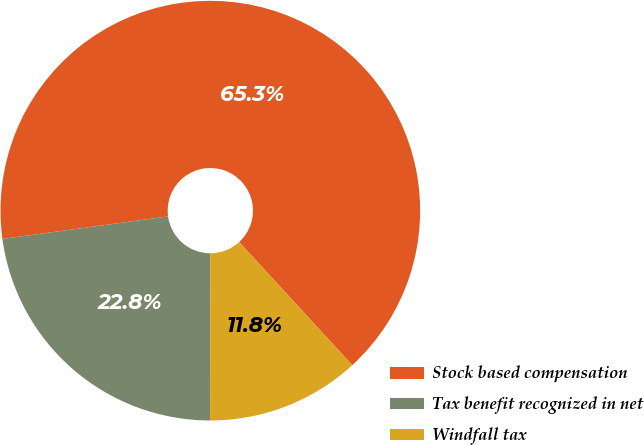<chart> <loc_0><loc_0><loc_500><loc_500><pie_chart><fcel>Stock based compensation<fcel>Tax benefit recognized in net<fcel>Windfall tax<nl><fcel>65.33%<fcel>22.83%<fcel>11.84%<nl></chart> 